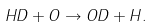<formula> <loc_0><loc_0><loc_500><loc_500>H D + O \rightarrow O D + H .</formula> 